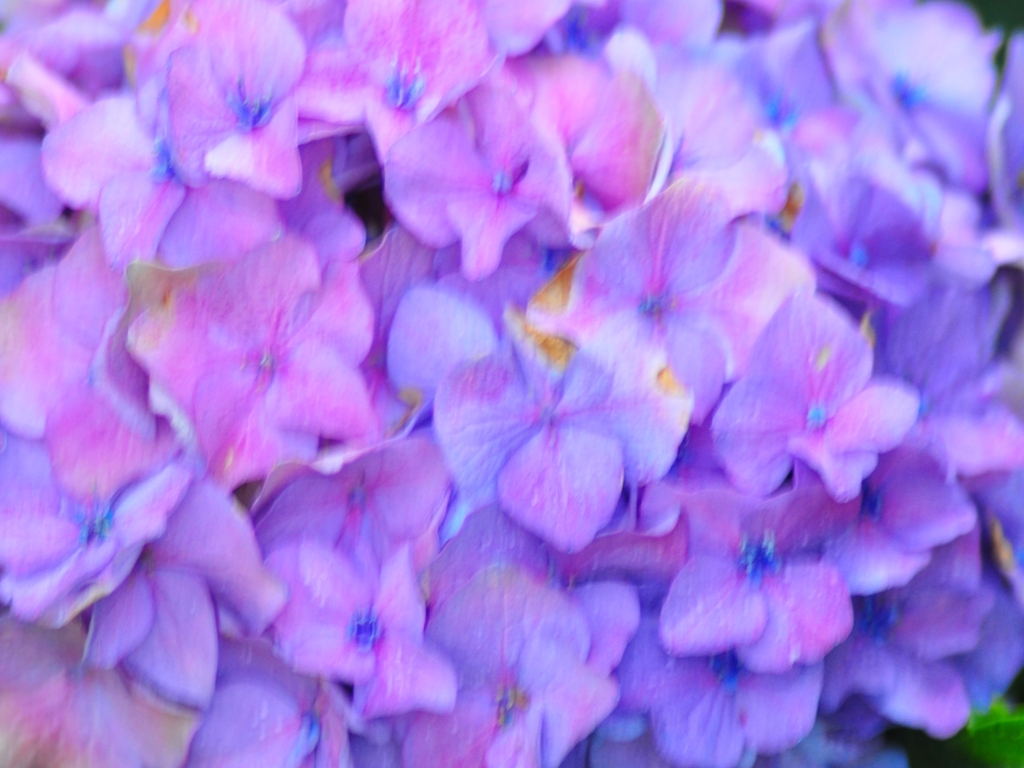Considering the time of day or lighting conditions, when do you think this photo was taken? Judging by the soft and diffuse quality of the light in the image, with no harsh shadows or bright highlights, it could suggest that the photo was taken on an overcast day or during a time when the sunlight was filtered, such as early morning or late afternoon. 